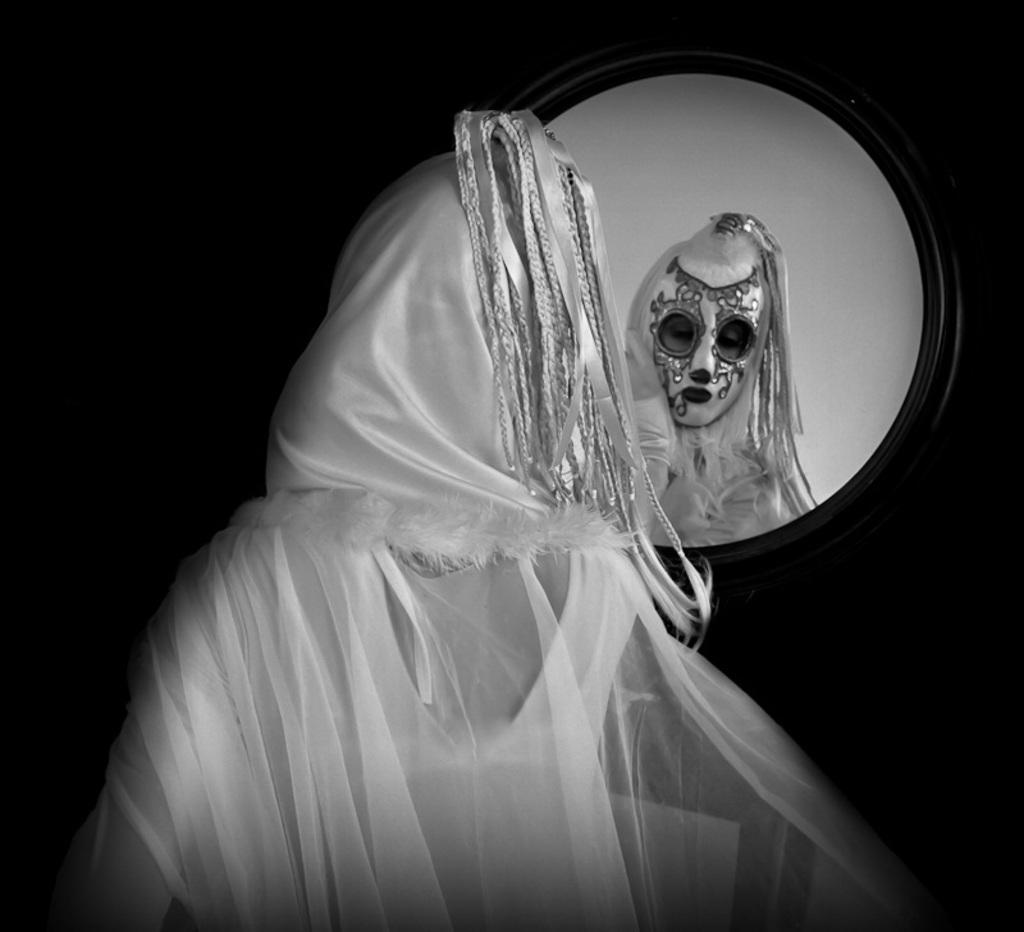What is the person in the image wearing? The person in the image is wearing a fancy dress. What object in the image can be used for self-reflection? There is a mirror in the image that can be used for self-reflection. Does the mirror show a reflection of the person in the image? Yes, the mirror reflects the person in the image. How would you describe the overall lighting in the image? The background of the image is dark. What type of trouble can be seen in the image? There is no trouble present in the image; it features a person wearing a fancy dress and a mirror reflecting them. What type of linen is visible in the image? There is no linen present in the image. 